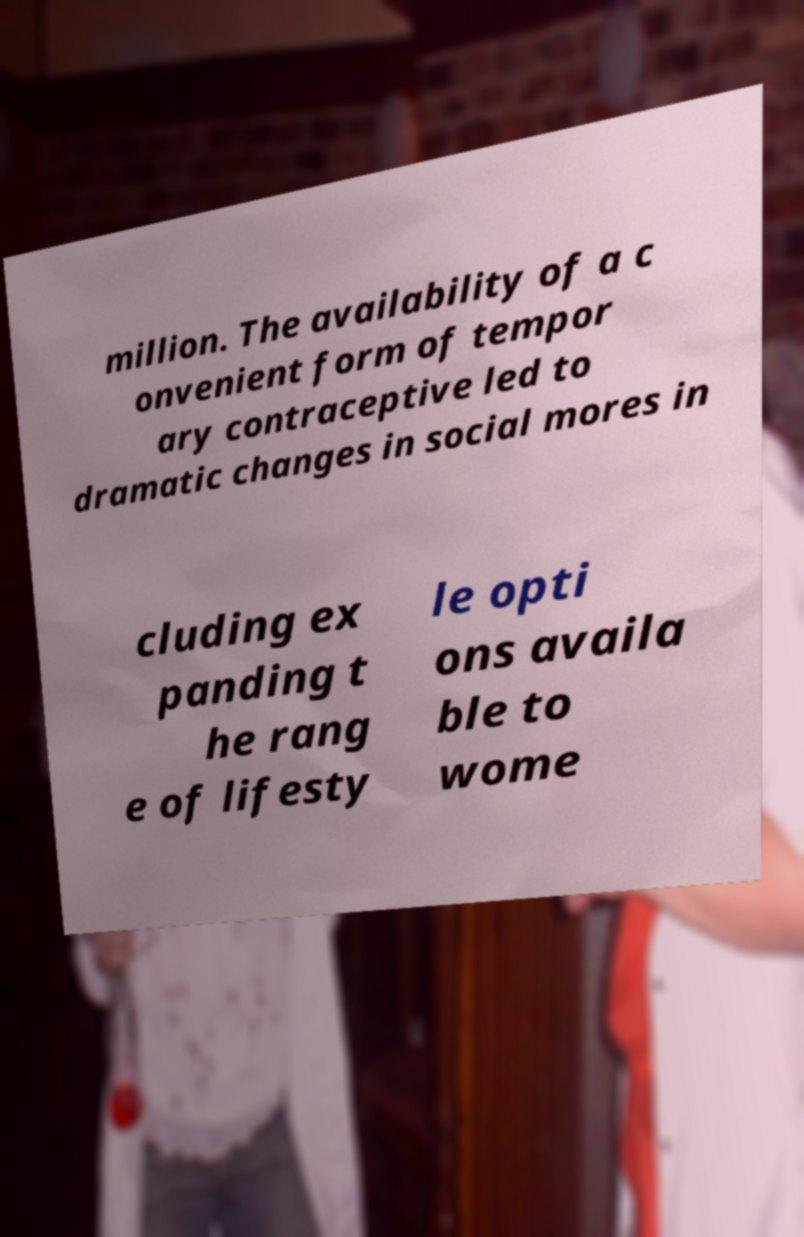Please read and relay the text visible in this image. What does it say? million. The availability of a c onvenient form of tempor ary contraceptive led to dramatic changes in social mores in cluding ex panding t he rang e of lifesty le opti ons availa ble to wome 